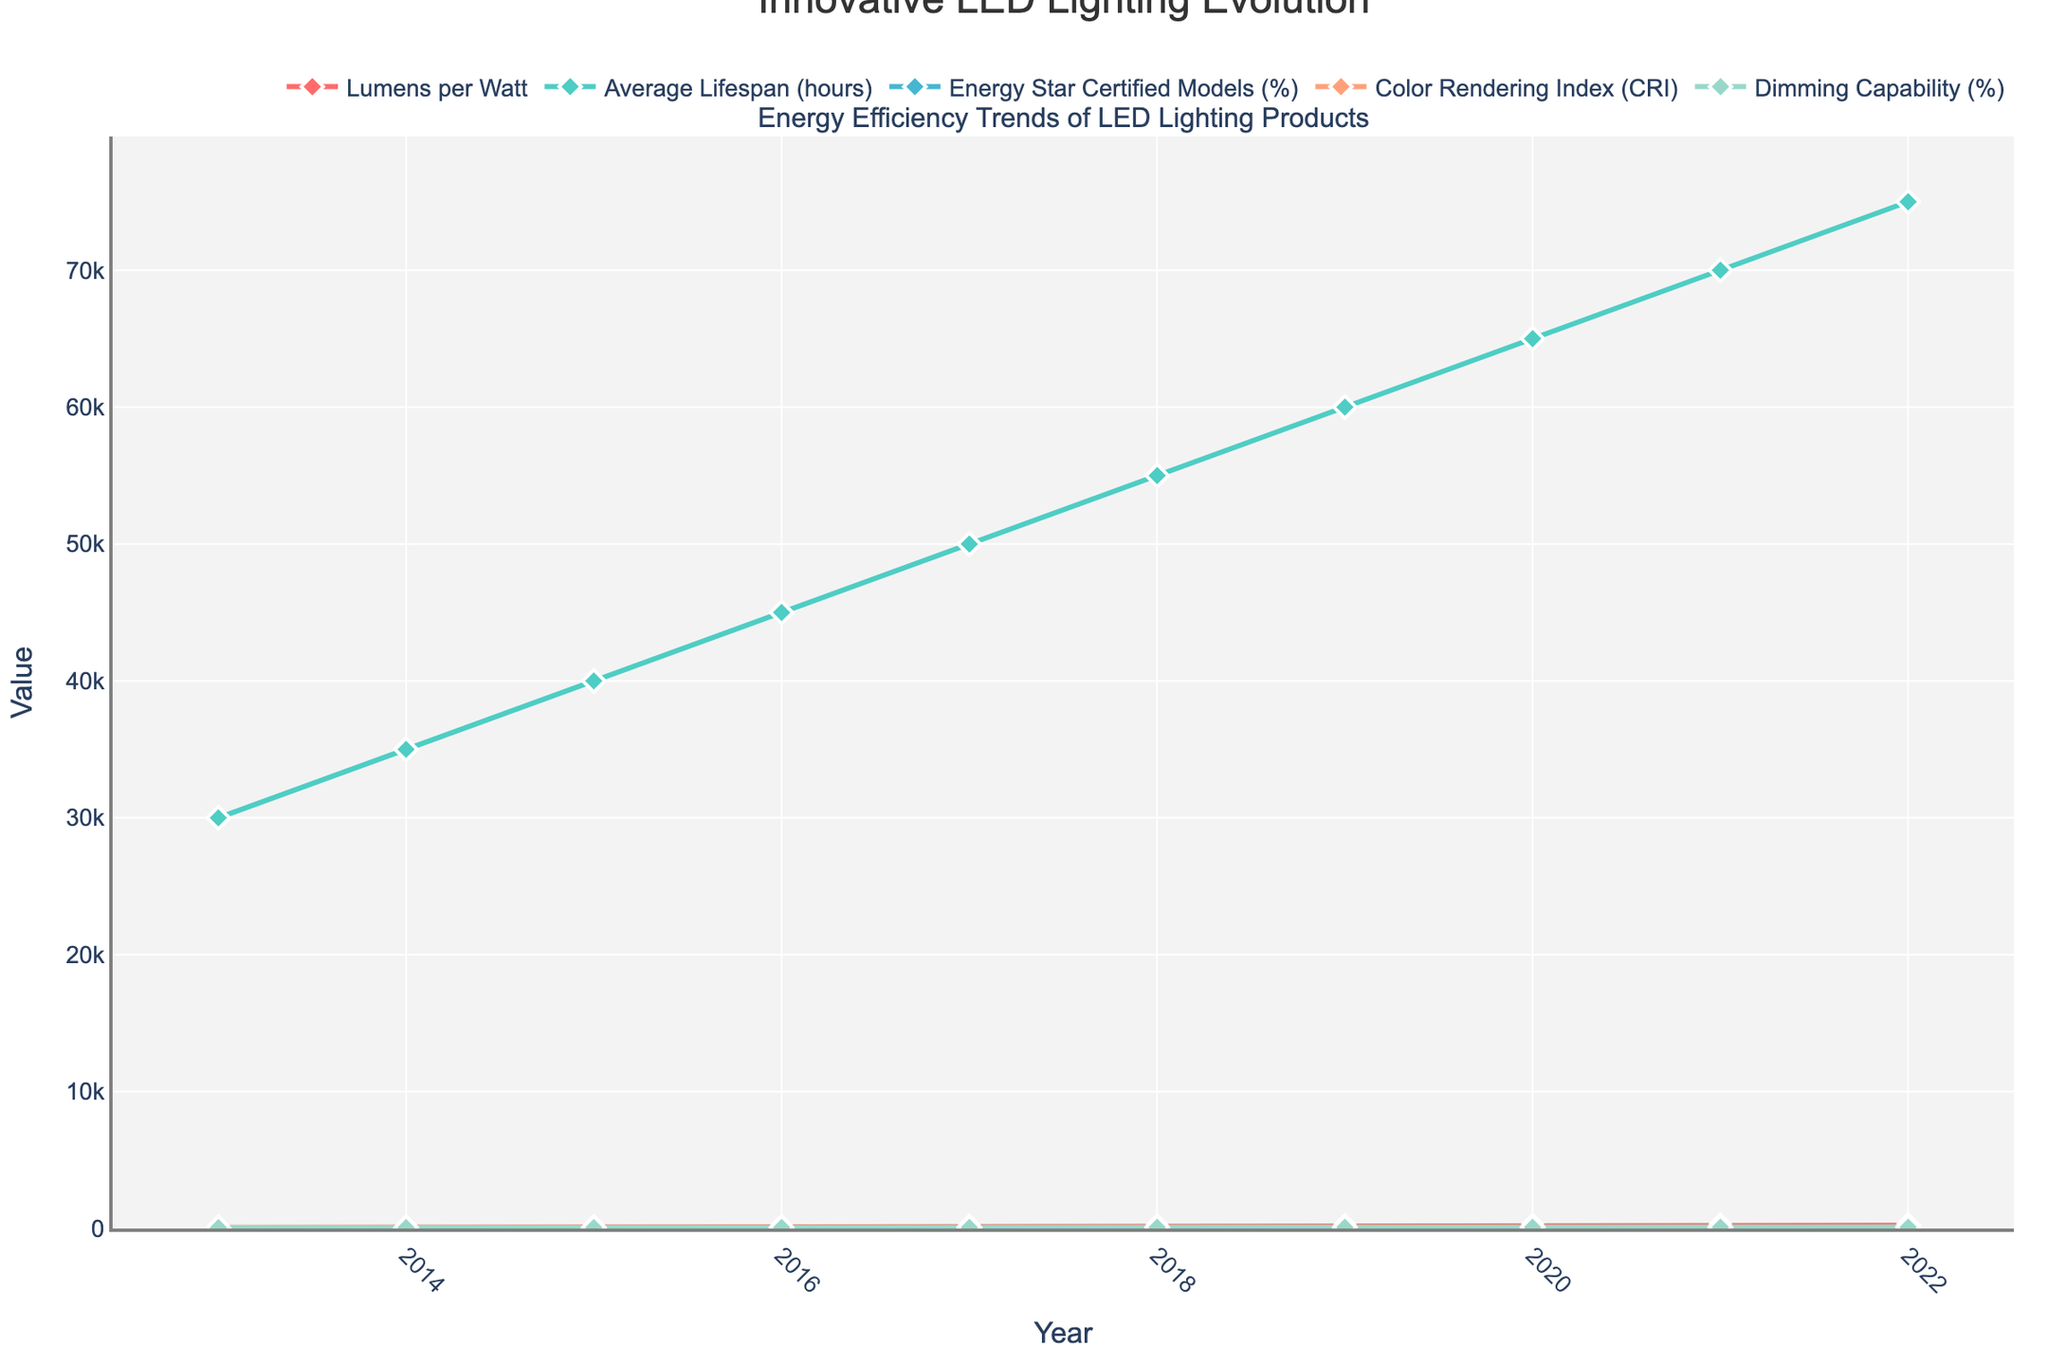What's the increase in Lumens per Watt from 2013 to 2022? The Lumens per Watt in 2013 was 70, and in 2022 it was 240. The increase is 240 - 70 = 170 Lumens per Watt.
Answer: 170 Which year saw the highest percentage of Energy Star Certified Models? Looking at the Energy Star Certified Models' percentage, 2022 had the highest at 97%.
Answer: 2022 How many years did it take for the Average Lifespan to exceed 60,000 hours? The Average Lifespan exceeded 60,000 hours in 2019. Starting from 2013, it took 2019 - 2013 = 6 years.
Answer: 6 years On average, how much did the Color Rendering Index (CRI) increase each year from 2013 to 2022? The CRI in 2013 was 80, and in 2022 it was 96. The total increase is 96 - 80 = 16 over 9 years, so the average yearly increase is 16 / 9 ≈ 1.78.
Answer: 1.78 In which year did Dimming Capability reach 80%? The Dimming Capability reached 80% in 2017.
Answer: 2017 What can be inferred about the relationship between Lumens per Watt and Average Lifespan over the decade? Both Lumens per Watt and Average Lifespan increased over the years from 2013 to 2022, indicating a positive trend in efficiency and longevity of LED lighting products.
Answer: Positive trend Compare the growth trends between Lumens per Watt and Dimming Capability over the years. Lumens per Watt showed a steady increase from 70 in 2013 to 240 in 2022, while Dimming Capability started at 60% in 2013 and reached 97% in 2022, both showing upward trends but at different scales.
Answer: Both increased How did the percentage of Energy Star Certified Models change from 2018 to 2020? The percentage of Energy Star Certified Models increased from 85% in 2018 to 92% in 2020.
Answer: Increased By how much did the Average Lifespan increase between 2016 and 2019? The Average Lifespan in 2016 was 45000 hours and in 2019 it was 60000 hours. The increase is 60000 - 45000 = 15000 hours.
Answer: 15000 hours Which metric shows the most significant improvement over the decade? Lumens per Watt shows the most significant improvement, increasing from 70 in 2013 to 240 in 2022.
Answer: Lumens per Watt 